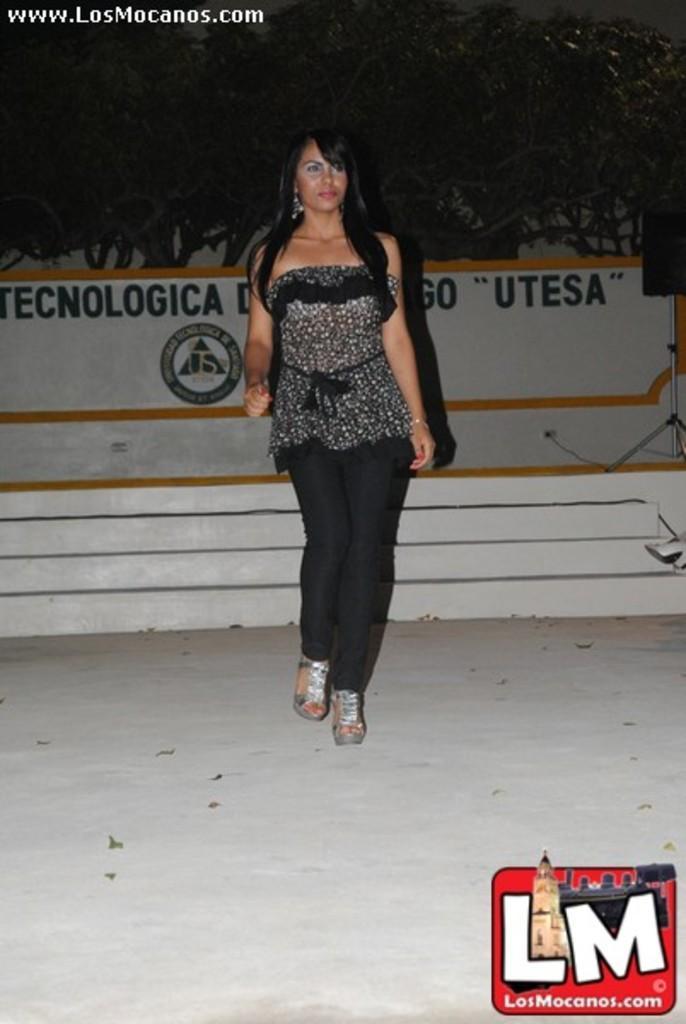Describe this image in one or two sentences. In this image we can see a woman standing on the ground. On the backside we can see the staircase, a wall with some text on it, a speaker on a stand and a group of trees. 